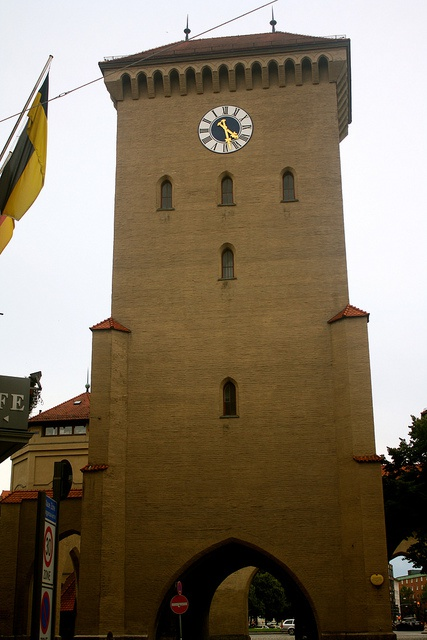Describe the objects in this image and their specific colors. I can see clock in white, beige, lightgray, darkgray, and gray tones, car in white, black, gray, lightgray, and darkgray tones, and car in white, black, darkgreen, maroon, and tan tones in this image. 